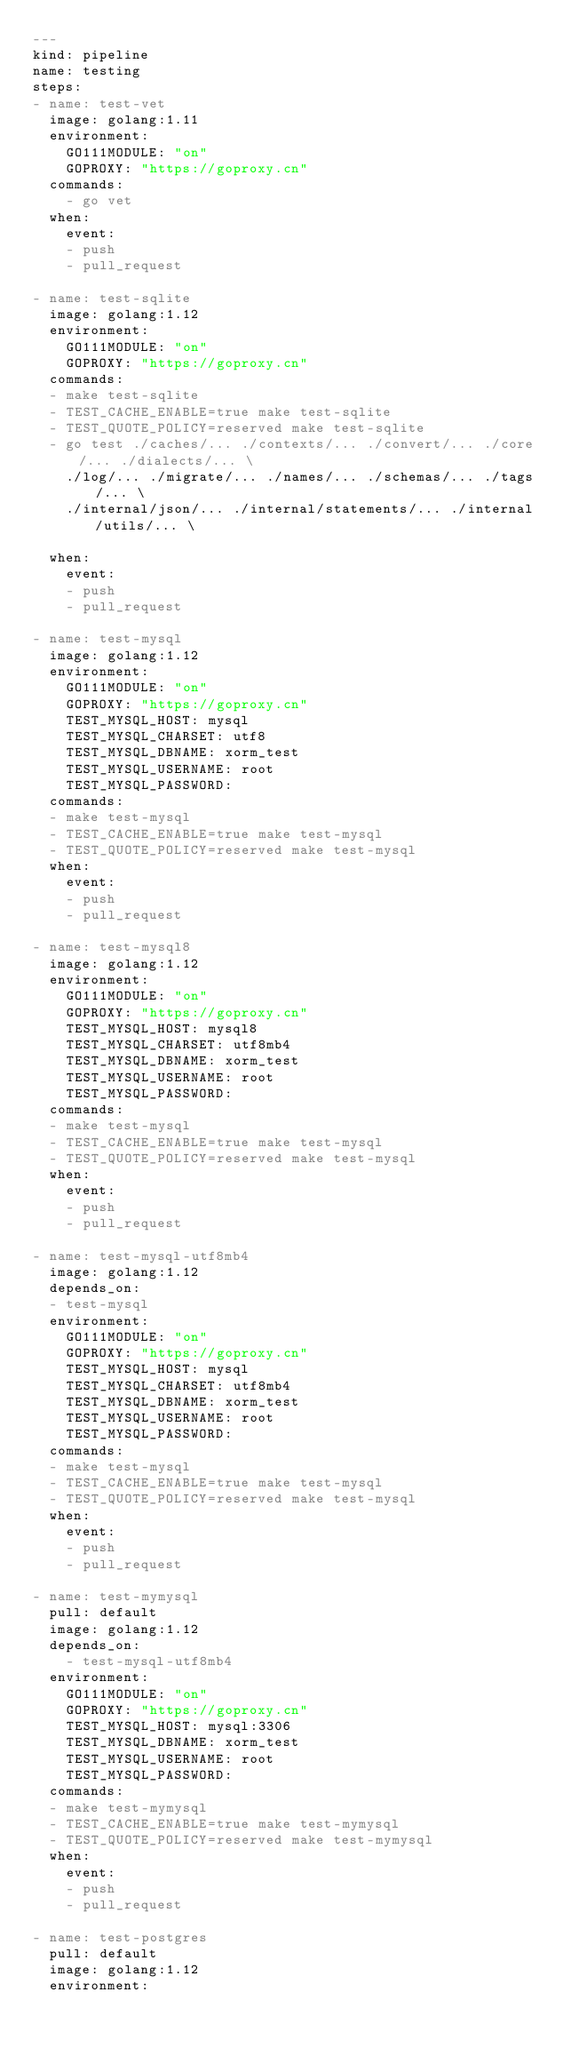<code> <loc_0><loc_0><loc_500><loc_500><_YAML_>---
kind: pipeline
name: testing
steps:
- name: test-vet
  image: golang:1.11
  environment:
    GO111MODULE: "on"
    GOPROXY: "https://goproxy.cn"
  commands:
    - go vet
  when:
    event:
    - push
    - pull_request

- name: test-sqlite
  image: golang:1.12
  environment:
    GO111MODULE: "on"
    GOPROXY: "https://goproxy.cn"
  commands:
  - make test-sqlite
  - TEST_CACHE_ENABLE=true make test-sqlite
  - TEST_QUOTE_POLICY=reserved make test-sqlite
  - go test ./caches/... ./contexts/... ./convert/... ./core/... ./dialects/... \
    ./log/... ./migrate/... ./names/... ./schemas/... ./tags/... \
    ./internal/json/... ./internal/statements/... ./internal/utils/... \

  when:
    event:
    - push
    - pull_request

- name: test-mysql
  image: golang:1.12
  environment:
    GO111MODULE: "on"
    GOPROXY: "https://goproxy.cn"
    TEST_MYSQL_HOST: mysql
    TEST_MYSQL_CHARSET: utf8
    TEST_MYSQL_DBNAME: xorm_test
    TEST_MYSQL_USERNAME: root
    TEST_MYSQL_PASSWORD:
  commands:
  - make test-mysql
  - TEST_CACHE_ENABLE=true make test-mysql
  - TEST_QUOTE_POLICY=reserved make test-mysql
  when:
    event:
    - push
    - pull_request

- name: test-mysql8
  image: golang:1.12
  environment:
    GO111MODULE: "on"
    GOPROXY: "https://goproxy.cn"
    TEST_MYSQL_HOST: mysql8
    TEST_MYSQL_CHARSET: utf8mb4
    TEST_MYSQL_DBNAME: xorm_test
    TEST_MYSQL_USERNAME: root
    TEST_MYSQL_PASSWORD:
  commands:
  - make test-mysql
  - TEST_CACHE_ENABLE=true make test-mysql
  - TEST_QUOTE_POLICY=reserved make test-mysql
  when:
    event:
    - push
    - pull_request

- name: test-mysql-utf8mb4
  image: golang:1.12
  depends_on:
  - test-mysql
  environment:
    GO111MODULE: "on"
    GOPROXY: "https://goproxy.cn"
    TEST_MYSQL_HOST: mysql
    TEST_MYSQL_CHARSET: utf8mb4
    TEST_MYSQL_DBNAME: xorm_test
    TEST_MYSQL_USERNAME: root
    TEST_MYSQL_PASSWORD:
  commands:
  - make test-mysql
  - TEST_CACHE_ENABLE=true make test-mysql
  - TEST_QUOTE_POLICY=reserved make test-mysql
  when:
    event:
    - push
    - pull_request

- name: test-mymysql
  pull: default
  image: golang:1.12
  depends_on:
    - test-mysql-utf8mb4
  environment:
    GO111MODULE: "on"
    GOPROXY: "https://goproxy.cn"
    TEST_MYSQL_HOST: mysql:3306
    TEST_MYSQL_DBNAME: xorm_test
    TEST_MYSQL_USERNAME: root
    TEST_MYSQL_PASSWORD:
  commands:
  - make test-mymysql
  - TEST_CACHE_ENABLE=true make test-mymysql
  - TEST_QUOTE_POLICY=reserved make test-mymysql
  when:
    event:
    - push
    - pull_request

- name: test-postgres
  pull: default
  image: golang:1.12
  environment:</code> 